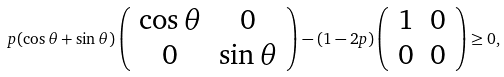Convert formula to latex. <formula><loc_0><loc_0><loc_500><loc_500>p ( \cos \theta + \sin \theta ) \left ( \begin{array} { c c } \cos \theta & 0 \\ 0 & \sin \theta \end{array} \right ) - ( 1 - 2 p ) \left ( \begin{array} { c c } 1 & 0 \\ 0 & 0 \end{array} \right ) \geq 0 ,</formula> 